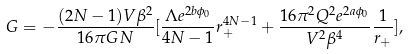<formula> <loc_0><loc_0><loc_500><loc_500>G = - \frac { ( 2 N - 1 ) V \beta ^ { 2 } } { 1 6 \pi G N } [ \frac { \Lambda e ^ { 2 b \phi _ { 0 } } } { 4 N - 1 } r _ { + } ^ { 4 N - 1 } + \frac { 1 6 \pi ^ { 2 } Q ^ { 2 } e ^ { 2 a \phi _ { 0 } } } { V ^ { 2 } \beta ^ { 4 } } \frac { 1 } { r _ { + } } ] ,</formula> 